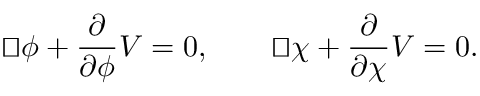Convert formula to latex. <formula><loc_0><loc_0><loc_500><loc_500>{ \sqcup \, \sqcap } \phi + \frac { \partial } { \partial \phi } V = 0 , \quad { \sqcup \, \sqcap } \chi + \frac { \partial } { \partial \chi } V = 0 .</formula> 